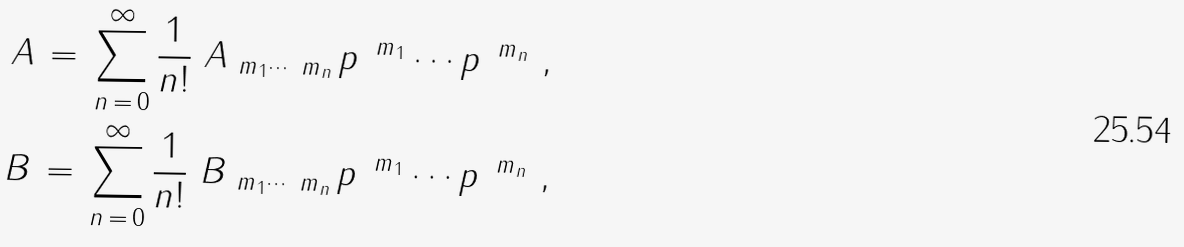Convert formula to latex. <formula><loc_0><loc_0><loc_500><loc_500>A \, = \, \sum _ { n \, = \, 0 } ^ { \infty } \frac { 1 } { n ! } \ A _ { \ m _ { 1 } \cdots \ m _ { n } } \, p ^ { \, \ m _ { 1 } } \cdots p ^ { \, \ m _ { n } } \ , \\ B \, = \, \sum _ { n \, = \, 0 } ^ { \infty } \frac { 1 } { n ! } \ B _ { \ m _ { 1 } \cdots \ m _ { n } } \, p ^ { \, \ m _ { 1 } } \cdots p ^ { \, \ m _ { n } } \ ,</formula> 